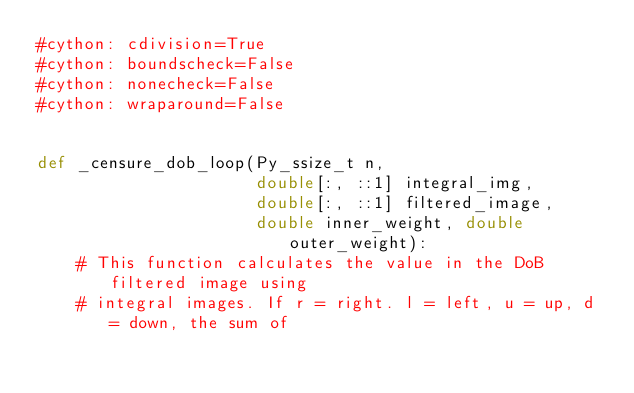<code> <loc_0><loc_0><loc_500><loc_500><_Cython_>#cython: cdivision=True
#cython: boundscheck=False
#cython: nonecheck=False
#cython: wraparound=False


def _censure_dob_loop(Py_ssize_t n,
                      double[:, ::1] integral_img,
                      double[:, ::1] filtered_image,
                      double inner_weight, double outer_weight):
    # This function calculates the value in the DoB filtered image using
    # integral images. If r = right. l = left, u = up, d = down, the sum of</code> 